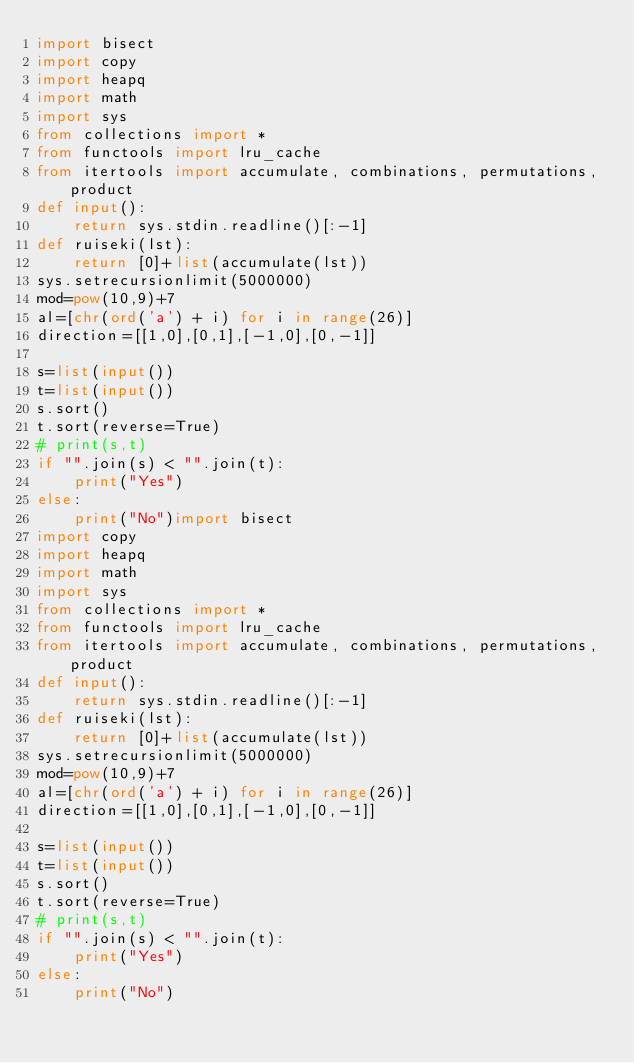Convert code to text. <code><loc_0><loc_0><loc_500><loc_500><_Python_>import bisect
import copy
import heapq
import math
import sys
from collections import *
from functools import lru_cache
from itertools import accumulate, combinations, permutations, product
def input():
    return sys.stdin.readline()[:-1]
def ruiseki(lst):
    return [0]+list(accumulate(lst))
sys.setrecursionlimit(5000000)
mod=pow(10,9)+7
al=[chr(ord('a') + i) for i in range(26)]
direction=[[1,0],[0,1],[-1,0],[0,-1]]

s=list(input())
t=list(input())
s.sort()
t.sort(reverse=True)
# print(s,t)
if "".join(s) < "".join(t):
    print("Yes")
else:
    print("No")import bisect
import copy
import heapq
import math
import sys
from collections import *
from functools import lru_cache
from itertools import accumulate, combinations, permutations, product
def input():
    return sys.stdin.readline()[:-1]
def ruiseki(lst):
    return [0]+list(accumulate(lst))
sys.setrecursionlimit(5000000)
mod=pow(10,9)+7
al=[chr(ord('a') + i) for i in range(26)]
direction=[[1,0],[0,1],[-1,0],[0,-1]]

s=list(input())
t=list(input())
s.sort()
t.sort(reverse=True)
# print(s,t)
if "".join(s) < "".join(t):
    print("Yes")
else:
    print("No")</code> 